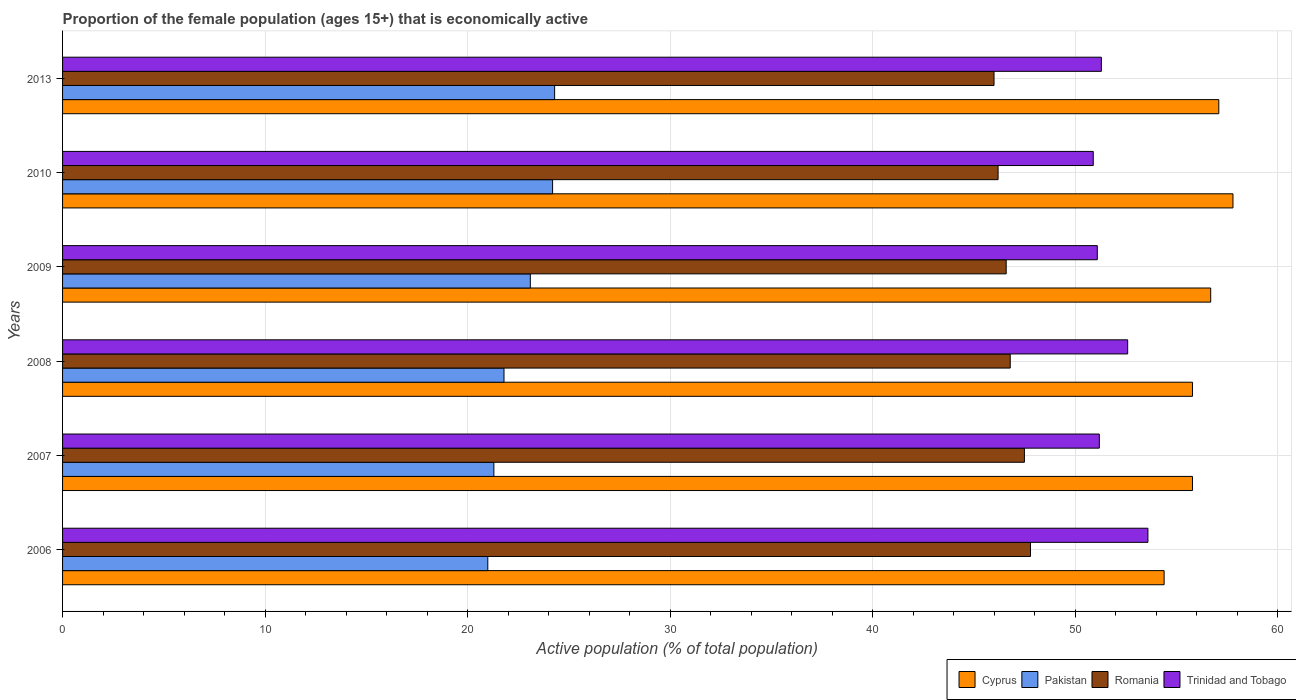How many different coloured bars are there?
Make the answer very short. 4. Are the number of bars on each tick of the Y-axis equal?
Make the answer very short. Yes. How many bars are there on the 4th tick from the top?
Offer a terse response. 4. What is the proportion of the female population that is economically active in Trinidad and Tobago in 2008?
Keep it short and to the point. 52.6. Across all years, what is the maximum proportion of the female population that is economically active in Pakistan?
Give a very brief answer. 24.3. Across all years, what is the minimum proportion of the female population that is economically active in Cyprus?
Keep it short and to the point. 54.4. In which year was the proportion of the female population that is economically active in Cyprus minimum?
Ensure brevity in your answer.  2006. What is the total proportion of the female population that is economically active in Romania in the graph?
Make the answer very short. 280.9. What is the difference between the proportion of the female population that is economically active in Trinidad and Tobago in 2008 and that in 2013?
Provide a succinct answer. 1.3. What is the difference between the proportion of the female population that is economically active in Cyprus in 2006 and the proportion of the female population that is economically active in Trinidad and Tobago in 2009?
Provide a short and direct response. 3.3. What is the average proportion of the female population that is economically active in Romania per year?
Make the answer very short. 46.82. What is the ratio of the proportion of the female population that is economically active in Romania in 2008 to that in 2010?
Your response must be concise. 1.01. Is the proportion of the female population that is economically active in Pakistan in 2008 less than that in 2013?
Provide a short and direct response. Yes. Is the difference between the proportion of the female population that is economically active in Romania in 2009 and 2013 greater than the difference between the proportion of the female population that is economically active in Trinidad and Tobago in 2009 and 2013?
Your answer should be compact. Yes. What is the difference between the highest and the lowest proportion of the female population that is economically active in Pakistan?
Provide a succinct answer. 3.3. Is the sum of the proportion of the female population that is economically active in Pakistan in 2006 and 2010 greater than the maximum proportion of the female population that is economically active in Trinidad and Tobago across all years?
Provide a short and direct response. No. Is it the case that in every year, the sum of the proportion of the female population that is economically active in Pakistan and proportion of the female population that is economically active in Cyprus is greater than the sum of proportion of the female population that is economically active in Trinidad and Tobago and proportion of the female population that is economically active in Romania?
Provide a succinct answer. No. What does the 4th bar from the top in 2010 represents?
Offer a very short reply. Cyprus. What does the 2nd bar from the bottom in 2010 represents?
Give a very brief answer. Pakistan. Is it the case that in every year, the sum of the proportion of the female population that is economically active in Pakistan and proportion of the female population that is economically active in Romania is greater than the proportion of the female population that is economically active in Trinidad and Tobago?
Your response must be concise. Yes. How many bars are there?
Your answer should be very brief. 24. Are the values on the major ticks of X-axis written in scientific E-notation?
Provide a succinct answer. No. How many legend labels are there?
Keep it short and to the point. 4. How are the legend labels stacked?
Provide a short and direct response. Horizontal. What is the title of the graph?
Offer a very short reply. Proportion of the female population (ages 15+) that is economically active. Does "Lower middle income" appear as one of the legend labels in the graph?
Your answer should be very brief. No. What is the label or title of the X-axis?
Make the answer very short. Active population (% of total population). What is the label or title of the Y-axis?
Your response must be concise. Years. What is the Active population (% of total population) of Cyprus in 2006?
Give a very brief answer. 54.4. What is the Active population (% of total population) of Pakistan in 2006?
Your answer should be very brief. 21. What is the Active population (% of total population) in Romania in 2006?
Provide a short and direct response. 47.8. What is the Active population (% of total population) in Trinidad and Tobago in 2006?
Offer a very short reply. 53.6. What is the Active population (% of total population) of Cyprus in 2007?
Make the answer very short. 55.8. What is the Active population (% of total population) in Pakistan in 2007?
Your answer should be compact. 21.3. What is the Active population (% of total population) in Romania in 2007?
Offer a terse response. 47.5. What is the Active population (% of total population) in Trinidad and Tobago in 2007?
Your answer should be very brief. 51.2. What is the Active population (% of total population) in Cyprus in 2008?
Offer a very short reply. 55.8. What is the Active population (% of total population) of Pakistan in 2008?
Offer a very short reply. 21.8. What is the Active population (% of total population) of Romania in 2008?
Keep it short and to the point. 46.8. What is the Active population (% of total population) in Trinidad and Tobago in 2008?
Provide a short and direct response. 52.6. What is the Active population (% of total population) in Cyprus in 2009?
Offer a very short reply. 56.7. What is the Active population (% of total population) of Pakistan in 2009?
Make the answer very short. 23.1. What is the Active population (% of total population) of Romania in 2009?
Your response must be concise. 46.6. What is the Active population (% of total population) of Trinidad and Tobago in 2009?
Give a very brief answer. 51.1. What is the Active population (% of total population) in Cyprus in 2010?
Ensure brevity in your answer.  57.8. What is the Active population (% of total population) in Pakistan in 2010?
Your response must be concise. 24.2. What is the Active population (% of total population) in Romania in 2010?
Give a very brief answer. 46.2. What is the Active population (% of total population) in Trinidad and Tobago in 2010?
Make the answer very short. 50.9. What is the Active population (% of total population) of Cyprus in 2013?
Keep it short and to the point. 57.1. What is the Active population (% of total population) in Pakistan in 2013?
Your answer should be compact. 24.3. What is the Active population (% of total population) of Trinidad and Tobago in 2013?
Your response must be concise. 51.3. Across all years, what is the maximum Active population (% of total population) of Cyprus?
Provide a succinct answer. 57.8. Across all years, what is the maximum Active population (% of total population) of Pakistan?
Provide a short and direct response. 24.3. Across all years, what is the maximum Active population (% of total population) of Romania?
Keep it short and to the point. 47.8. Across all years, what is the maximum Active population (% of total population) in Trinidad and Tobago?
Your answer should be very brief. 53.6. Across all years, what is the minimum Active population (% of total population) of Cyprus?
Ensure brevity in your answer.  54.4. Across all years, what is the minimum Active population (% of total population) in Pakistan?
Provide a short and direct response. 21. Across all years, what is the minimum Active population (% of total population) in Romania?
Offer a terse response. 46. Across all years, what is the minimum Active population (% of total population) in Trinidad and Tobago?
Your response must be concise. 50.9. What is the total Active population (% of total population) in Cyprus in the graph?
Provide a short and direct response. 337.6. What is the total Active population (% of total population) of Pakistan in the graph?
Keep it short and to the point. 135.7. What is the total Active population (% of total population) of Romania in the graph?
Keep it short and to the point. 280.9. What is the total Active population (% of total population) of Trinidad and Tobago in the graph?
Your answer should be compact. 310.7. What is the difference between the Active population (% of total population) in Pakistan in 2006 and that in 2007?
Provide a succinct answer. -0.3. What is the difference between the Active population (% of total population) of Romania in 2006 and that in 2008?
Your answer should be very brief. 1. What is the difference between the Active population (% of total population) of Trinidad and Tobago in 2006 and that in 2008?
Offer a very short reply. 1. What is the difference between the Active population (% of total population) in Cyprus in 2006 and that in 2009?
Your response must be concise. -2.3. What is the difference between the Active population (% of total population) of Pakistan in 2006 and that in 2009?
Provide a short and direct response. -2.1. What is the difference between the Active population (% of total population) in Trinidad and Tobago in 2006 and that in 2009?
Your answer should be compact. 2.5. What is the difference between the Active population (% of total population) of Cyprus in 2006 and that in 2010?
Your response must be concise. -3.4. What is the difference between the Active population (% of total population) of Romania in 2006 and that in 2010?
Your answer should be compact. 1.6. What is the difference between the Active population (% of total population) in Trinidad and Tobago in 2006 and that in 2010?
Give a very brief answer. 2.7. What is the difference between the Active population (% of total population) in Pakistan in 2007 and that in 2008?
Your answer should be very brief. -0.5. What is the difference between the Active population (% of total population) in Trinidad and Tobago in 2007 and that in 2008?
Provide a succinct answer. -1.4. What is the difference between the Active population (% of total population) in Pakistan in 2007 and that in 2009?
Your answer should be compact. -1.8. What is the difference between the Active population (% of total population) of Trinidad and Tobago in 2007 and that in 2009?
Your answer should be very brief. 0.1. What is the difference between the Active population (% of total population) in Pakistan in 2007 and that in 2010?
Offer a very short reply. -2.9. What is the difference between the Active population (% of total population) of Romania in 2007 and that in 2013?
Make the answer very short. 1.5. What is the difference between the Active population (% of total population) of Trinidad and Tobago in 2007 and that in 2013?
Provide a succinct answer. -0.1. What is the difference between the Active population (% of total population) of Romania in 2008 and that in 2009?
Keep it short and to the point. 0.2. What is the difference between the Active population (% of total population) in Trinidad and Tobago in 2008 and that in 2009?
Your answer should be very brief. 1.5. What is the difference between the Active population (% of total population) of Romania in 2008 and that in 2010?
Provide a short and direct response. 0.6. What is the difference between the Active population (% of total population) of Cyprus in 2008 and that in 2013?
Provide a succinct answer. -1.3. What is the difference between the Active population (% of total population) in Pakistan in 2008 and that in 2013?
Provide a succinct answer. -2.5. What is the difference between the Active population (% of total population) of Trinidad and Tobago in 2008 and that in 2013?
Ensure brevity in your answer.  1.3. What is the difference between the Active population (% of total population) of Trinidad and Tobago in 2009 and that in 2010?
Keep it short and to the point. 0.2. What is the difference between the Active population (% of total population) in Cyprus in 2009 and that in 2013?
Give a very brief answer. -0.4. What is the difference between the Active population (% of total population) of Romania in 2009 and that in 2013?
Make the answer very short. 0.6. What is the difference between the Active population (% of total population) in Trinidad and Tobago in 2009 and that in 2013?
Your answer should be compact. -0.2. What is the difference between the Active population (% of total population) of Cyprus in 2010 and that in 2013?
Provide a succinct answer. 0.7. What is the difference between the Active population (% of total population) of Pakistan in 2010 and that in 2013?
Give a very brief answer. -0.1. What is the difference between the Active population (% of total population) of Romania in 2010 and that in 2013?
Offer a very short reply. 0.2. What is the difference between the Active population (% of total population) of Trinidad and Tobago in 2010 and that in 2013?
Offer a terse response. -0.4. What is the difference between the Active population (% of total population) in Cyprus in 2006 and the Active population (% of total population) in Pakistan in 2007?
Your answer should be compact. 33.1. What is the difference between the Active population (% of total population) of Pakistan in 2006 and the Active population (% of total population) of Romania in 2007?
Give a very brief answer. -26.5. What is the difference between the Active population (% of total population) of Pakistan in 2006 and the Active population (% of total population) of Trinidad and Tobago in 2007?
Make the answer very short. -30.2. What is the difference between the Active population (% of total population) in Cyprus in 2006 and the Active population (% of total population) in Pakistan in 2008?
Give a very brief answer. 32.6. What is the difference between the Active population (% of total population) in Cyprus in 2006 and the Active population (% of total population) in Romania in 2008?
Your answer should be compact. 7.6. What is the difference between the Active population (% of total population) in Cyprus in 2006 and the Active population (% of total population) in Trinidad and Tobago in 2008?
Your response must be concise. 1.8. What is the difference between the Active population (% of total population) of Pakistan in 2006 and the Active population (% of total population) of Romania in 2008?
Offer a very short reply. -25.8. What is the difference between the Active population (% of total population) of Pakistan in 2006 and the Active population (% of total population) of Trinidad and Tobago in 2008?
Offer a very short reply. -31.6. What is the difference between the Active population (% of total population) in Romania in 2006 and the Active population (% of total population) in Trinidad and Tobago in 2008?
Provide a short and direct response. -4.8. What is the difference between the Active population (% of total population) of Cyprus in 2006 and the Active population (% of total population) of Pakistan in 2009?
Your response must be concise. 31.3. What is the difference between the Active population (% of total population) of Pakistan in 2006 and the Active population (% of total population) of Romania in 2009?
Make the answer very short. -25.6. What is the difference between the Active population (% of total population) of Pakistan in 2006 and the Active population (% of total population) of Trinidad and Tobago in 2009?
Keep it short and to the point. -30.1. What is the difference between the Active population (% of total population) of Romania in 2006 and the Active population (% of total population) of Trinidad and Tobago in 2009?
Give a very brief answer. -3.3. What is the difference between the Active population (% of total population) of Cyprus in 2006 and the Active population (% of total population) of Pakistan in 2010?
Keep it short and to the point. 30.2. What is the difference between the Active population (% of total population) in Cyprus in 2006 and the Active population (% of total population) in Romania in 2010?
Provide a succinct answer. 8.2. What is the difference between the Active population (% of total population) in Cyprus in 2006 and the Active population (% of total population) in Trinidad and Tobago in 2010?
Your answer should be very brief. 3.5. What is the difference between the Active population (% of total population) of Pakistan in 2006 and the Active population (% of total population) of Romania in 2010?
Your response must be concise. -25.2. What is the difference between the Active population (% of total population) in Pakistan in 2006 and the Active population (% of total population) in Trinidad and Tobago in 2010?
Provide a succinct answer. -29.9. What is the difference between the Active population (% of total population) in Cyprus in 2006 and the Active population (% of total population) in Pakistan in 2013?
Provide a short and direct response. 30.1. What is the difference between the Active population (% of total population) of Cyprus in 2006 and the Active population (% of total population) of Trinidad and Tobago in 2013?
Make the answer very short. 3.1. What is the difference between the Active population (% of total population) in Pakistan in 2006 and the Active population (% of total population) in Romania in 2013?
Ensure brevity in your answer.  -25. What is the difference between the Active population (% of total population) in Pakistan in 2006 and the Active population (% of total population) in Trinidad and Tobago in 2013?
Ensure brevity in your answer.  -30.3. What is the difference between the Active population (% of total population) of Cyprus in 2007 and the Active population (% of total population) of Trinidad and Tobago in 2008?
Ensure brevity in your answer.  3.2. What is the difference between the Active population (% of total population) of Pakistan in 2007 and the Active population (% of total population) of Romania in 2008?
Offer a very short reply. -25.5. What is the difference between the Active population (% of total population) in Pakistan in 2007 and the Active population (% of total population) in Trinidad and Tobago in 2008?
Provide a short and direct response. -31.3. What is the difference between the Active population (% of total population) of Romania in 2007 and the Active population (% of total population) of Trinidad and Tobago in 2008?
Give a very brief answer. -5.1. What is the difference between the Active population (% of total population) of Cyprus in 2007 and the Active population (% of total population) of Pakistan in 2009?
Make the answer very short. 32.7. What is the difference between the Active population (% of total population) of Cyprus in 2007 and the Active population (% of total population) of Romania in 2009?
Offer a terse response. 9.2. What is the difference between the Active population (% of total population) of Cyprus in 2007 and the Active population (% of total population) of Trinidad and Tobago in 2009?
Your answer should be very brief. 4.7. What is the difference between the Active population (% of total population) in Pakistan in 2007 and the Active population (% of total population) in Romania in 2009?
Make the answer very short. -25.3. What is the difference between the Active population (% of total population) of Pakistan in 2007 and the Active population (% of total population) of Trinidad and Tobago in 2009?
Give a very brief answer. -29.8. What is the difference between the Active population (% of total population) of Romania in 2007 and the Active population (% of total population) of Trinidad and Tobago in 2009?
Offer a terse response. -3.6. What is the difference between the Active population (% of total population) in Cyprus in 2007 and the Active population (% of total population) in Pakistan in 2010?
Keep it short and to the point. 31.6. What is the difference between the Active population (% of total population) in Cyprus in 2007 and the Active population (% of total population) in Romania in 2010?
Offer a terse response. 9.6. What is the difference between the Active population (% of total population) of Cyprus in 2007 and the Active population (% of total population) of Trinidad and Tobago in 2010?
Provide a short and direct response. 4.9. What is the difference between the Active population (% of total population) of Pakistan in 2007 and the Active population (% of total population) of Romania in 2010?
Ensure brevity in your answer.  -24.9. What is the difference between the Active population (% of total population) in Pakistan in 2007 and the Active population (% of total population) in Trinidad and Tobago in 2010?
Provide a succinct answer. -29.6. What is the difference between the Active population (% of total population) of Cyprus in 2007 and the Active population (% of total population) of Pakistan in 2013?
Your answer should be compact. 31.5. What is the difference between the Active population (% of total population) of Cyprus in 2007 and the Active population (% of total population) of Romania in 2013?
Offer a terse response. 9.8. What is the difference between the Active population (% of total population) of Pakistan in 2007 and the Active population (% of total population) of Romania in 2013?
Give a very brief answer. -24.7. What is the difference between the Active population (% of total population) of Cyprus in 2008 and the Active population (% of total population) of Pakistan in 2009?
Make the answer very short. 32.7. What is the difference between the Active population (% of total population) in Cyprus in 2008 and the Active population (% of total population) in Romania in 2009?
Your response must be concise. 9.2. What is the difference between the Active population (% of total population) in Pakistan in 2008 and the Active population (% of total population) in Romania in 2009?
Ensure brevity in your answer.  -24.8. What is the difference between the Active population (% of total population) of Pakistan in 2008 and the Active population (% of total population) of Trinidad and Tobago in 2009?
Your response must be concise. -29.3. What is the difference between the Active population (% of total population) of Cyprus in 2008 and the Active population (% of total population) of Pakistan in 2010?
Provide a short and direct response. 31.6. What is the difference between the Active population (% of total population) in Cyprus in 2008 and the Active population (% of total population) in Romania in 2010?
Provide a succinct answer. 9.6. What is the difference between the Active population (% of total population) of Pakistan in 2008 and the Active population (% of total population) of Romania in 2010?
Offer a very short reply. -24.4. What is the difference between the Active population (% of total population) of Pakistan in 2008 and the Active population (% of total population) of Trinidad and Tobago in 2010?
Ensure brevity in your answer.  -29.1. What is the difference between the Active population (% of total population) of Cyprus in 2008 and the Active population (% of total population) of Pakistan in 2013?
Offer a terse response. 31.5. What is the difference between the Active population (% of total population) in Cyprus in 2008 and the Active population (% of total population) in Trinidad and Tobago in 2013?
Provide a short and direct response. 4.5. What is the difference between the Active population (% of total population) in Pakistan in 2008 and the Active population (% of total population) in Romania in 2013?
Provide a short and direct response. -24.2. What is the difference between the Active population (% of total population) of Pakistan in 2008 and the Active population (% of total population) of Trinidad and Tobago in 2013?
Offer a terse response. -29.5. What is the difference between the Active population (% of total population) of Romania in 2008 and the Active population (% of total population) of Trinidad and Tobago in 2013?
Provide a short and direct response. -4.5. What is the difference between the Active population (% of total population) in Cyprus in 2009 and the Active population (% of total population) in Pakistan in 2010?
Your answer should be compact. 32.5. What is the difference between the Active population (% of total population) of Cyprus in 2009 and the Active population (% of total population) of Romania in 2010?
Provide a short and direct response. 10.5. What is the difference between the Active population (% of total population) of Pakistan in 2009 and the Active population (% of total population) of Romania in 2010?
Your answer should be compact. -23.1. What is the difference between the Active population (% of total population) in Pakistan in 2009 and the Active population (% of total population) in Trinidad and Tobago in 2010?
Keep it short and to the point. -27.8. What is the difference between the Active population (% of total population) of Romania in 2009 and the Active population (% of total population) of Trinidad and Tobago in 2010?
Provide a succinct answer. -4.3. What is the difference between the Active population (% of total population) of Cyprus in 2009 and the Active population (% of total population) of Pakistan in 2013?
Provide a succinct answer. 32.4. What is the difference between the Active population (% of total population) of Pakistan in 2009 and the Active population (% of total population) of Romania in 2013?
Your answer should be compact. -22.9. What is the difference between the Active population (% of total population) of Pakistan in 2009 and the Active population (% of total population) of Trinidad and Tobago in 2013?
Your answer should be very brief. -28.2. What is the difference between the Active population (% of total population) in Romania in 2009 and the Active population (% of total population) in Trinidad and Tobago in 2013?
Ensure brevity in your answer.  -4.7. What is the difference between the Active population (% of total population) in Cyprus in 2010 and the Active population (% of total population) in Pakistan in 2013?
Your answer should be compact. 33.5. What is the difference between the Active population (% of total population) of Pakistan in 2010 and the Active population (% of total population) of Romania in 2013?
Provide a succinct answer. -21.8. What is the difference between the Active population (% of total population) in Pakistan in 2010 and the Active population (% of total population) in Trinidad and Tobago in 2013?
Your response must be concise. -27.1. What is the difference between the Active population (% of total population) in Romania in 2010 and the Active population (% of total population) in Trinidad and Tobago in 2013?
Your answer should be very brief. -5.1. What is the average Active population (% of total population) of Cyprus per year?
Ensure brevity in your answer.  56.27. What is the average Active population (% of total population) of Pakistan per year?
Provide a short and direct response. 22.62. What is the average Active population (% of total population) of Romania per year?
Ensure brevity in your answer.  46.82. What is the average Active population (% of total population) in Trinidad and Tobago per year?
Your answer should be compact. 51.78. In the year 2006, what is the difference between the Active population (% of total population) of Cyprus and Active population (% of total population) of Pakistan?
Offer a terse response. 33.4. In the year 2006, what is the difference between the Active population (% of total population) of Cyprus and Active population (% of total population) of Romania?
Make the answer very short. 6.6. In the year 2006, what is the difference between the Active population (% of total population) of Cyprus and Active population (% of total population) of Trinidad and Tobago?
Offer a very short reply. 0.8. In the year 2006, what is the difference between the Active population (% of total population) in Pakistan and Active population (% of total population) in Romania?
Offer a very short reply. -26.8. In the year 2006, what is the difference between the Active population (% of total population) in Pakistan and Active population (% of total population) in Trinidad and Tobago?
Offer a terse response. -32.6. In the year 2006, what is the difference between the Active population (% of total population) of Romania and Active population (% of total population) of Trinidad and Tobago?
Make the answer very short. -5.8. In the year 2007, what is the difference between the Active population (% of total population) in Cyprus and Active population (% of total population) in Pakistan?
Your answer should be compact. 34.5. In the year 2007, what is the difference between the Active population (% of total population) in Pakistan and Active population (% of total population) in Romania?
Your response must be concise. -26.2. In the year 2007, what is the difference between the Active population (% of total population) of Pakistan and Active population (% of total population) of Trinidad and Tobago?
Make the answer very short. -29.9. In the year 2007, what is the difference between the Active population (% of total population) in Romania and Active population (% of total population) in Trinidad and Tobago?
Offer a terse response. -3.7. In the year 2008, what is the difference between the Active population (% of total population) of Cyprus and Active population (% of total population) of Pakistan?
Ensure brevity in your answer.  34. In the year 2008, what is the difference between the Active population (% of total population) in Cyprus and Active population (% of total population) in Romania?
Your response must be concise. 9. In the year 2008, what is the difference between the Active population (% of total population) of Pakistan and Active population (% of total population) of Romania?
Give a very brief answer. -25. In the year 2008, what is the difference between the Active population (% of total population) in Pakistan and Active population (% of total population) in Trinidad and Tobago?
Keep it short and to the point. -30.8. In the year 2009, what is the difference between the Active population (% of total population) of Cyprus and Active population (% of total population) of Pakistan?
Provide a short and direct response. 33.6. In the year 2009, what is the difference between the Active population (% of total population) of Pakistan and Active population (% of total population) of Romania?
Your answer should be very brief. -23.5. In the year 2009, what is the difference between the Active population (% of total population) of Romania and Active population (% of total population) of Trinidad and Tobago?
Make the answer very short. -4.5. In the year 2010, what is the difference between the Active population (% of total population) in Cyprus and Active population (% of total population) in Pakistan?
Your response must be concise. 33.6. In the year 2010, what is the difference between the Active population (% of total population) of Cyprus and Active population (% of total population) of Romania?
Your response must be concise. 11.6. In the year 2010, what is the difference between the Active population (% of total population) in Pakistan and Active population (% of total population) in Romania?
Your answer should be compact. -22. In the year 2010, what is the difference between the Active population (% of total population) in Pakistan and Active population (% of total population) in Trinidad and Tobago?
Provide a succinct answer. -26.7. In the year 2013, what is the difference between the Active population (% of total population) of Cyprus and Active population (% of total population) of Pakistan?
Offer a terse response. 32.8. In the year 2013, what is the difference between the Active population (% of total population) of Cyprus and Active population (% of total population) of Trinidad and Tobago?
Offer a terse response. 5.8. In the year 2013, what is the difference between the Active population (% of total population) in Pakistan and Active population (% of total population) in Romania?
Make the answer very short. -21.7. What is the ratio of the Active population (% of total population) of Cyprus in 2006 to that in 2007?
Offer a terse response. 0.97. What is the ratio of the Active population (% of total population) of Pakistan in 2006 to that in 2007?
Your answer should be compact. 0.99. What is the ratio of the Active population (% of total population) of Romania in 2006 to that in 2007?
Your answer should be very brief. 1.01. What is the ratio of the Active population (% of total population) of Trinidad and Tobago in 2006 to that in 2007?
Give a very brief answer. 1.05. What is the ratio of the Active population (% of total population) of Cyprus in 2006 to that in 2008?
Provide a succinct answer. 0.97. What is the ratio of the Active population (% of total population) in Pakistan in 2006 to that in 2008?
Make the answer very short. 0.96. What is the ratio of the Active population (% of total population) in Romania in 2006 to that in 2008?
Keep it short and to the point. 1.02. What is the ratio of the Active population (% of total population) of Trinidad and Tobago in 2006 to that in 2008?
Make the answer very short. 1.02. What is the ratio of the Active population (% of total population) in Cyprus in 2006 to that in 2009?
Give a very brief answer. 0.96. What is the ratio of the Active population (% of total population) in Romania in 2006 to that in 2009?
Offer a terse response. 1.03. What is the ratio of the Active population (% of total population) in Trinidad and Tobago in 2006 to that in 2009?
Offer a terse response. 1.05. What is the ratio of the Active population (% of total population) in Pakistan in 2006 to that in 2010?
Offer a terse response. 0.87. What is the ratio of the Active population (% of total population) in Romania in 2006 to that in 2010?
Make the answer very short. 1.03. What is the ratio of the Active population (% of total population) of Trinidad and Tobago in 2006 to that in 2010?
Make the answer very short. 1.05. What is the ratio of the Active population (% of total population) of Cyprus in 2006 to that in 2013?
Your response must be concise. 0.95. What is the ratio of the Active population (% of total population) of Pakistan in 2006 to that in 2013?
Keep it short and to the point. 0.86. What is the ratio of the Active population (% of total population) of Romania in 2006 to that in 2013?
Ensure brevity in your answer.  1.04. What is the ratio of the Active population (% of total population) in Trinidad and Tobago in 2006 to that in 2013?
Provide a succinct answer. 1.04. What is the ratio of the Active population (% of total population) of Pakistan in 2007 to that in 2008?
Your answer should be very brief. 0.98. What is the ratio of the Active population (% of total population) in Romania in 2007 to that in 2008?
Offer a terse response. 1.01. What is the ratio of the Active population (% of total population) of Trinidad and Tobago in 2007 to that in 2008?
Give a very brief answer. 0.97. What is the ratio of the Active population (% of total population) of Cyprus in 2007 to that in 2009?
Give a very brief answer. 0.98. What is the ratio of the Active population (% of total population) in Pakistan in 2007 to that in 2009?
Make the answer very short. 0.92. What is the ratio of the Active population (% of total population) of Romania in 2007 to that in 2009?
Offer a terse response. 1.02. What is the ratio of the Active population (% of total population) of Cyprus in 2007 to that in 2010?
Give a very brief answer. 0.97. What is the ratio of the Active population (% of total population) in Pakistan in 2007 to that in 2010?
Provide a succinct answer. 0.88. What is the ratio of the Active population (% of total population) of Romania in 2007 to that in 2010?
Provide a succinct answer. 1.03. What is the ratio of the Active population (% of total population) in Trinidad and Tobago in 2007 to that in 2010?
Ensure brevity in your answer.  1.01. What is the ratio of the Active population (% of total population) in Cyprus in 2007 to that in 2013?
Ensure brevity in your answer.  0.98. What is the ratio of the Active population (% of total population) of Pakistan in 2007 to that in 2013?
Ensure brevity in your answer.  0.88. What is the ratio of the Active population (% of total population) of Romania in 2007 to that in 2013?
Provide a succinct answer. 1.03. What is the ratio of the Active population (% of total population) in Trinidad and Tobago in 2007 to that in 2013?
Make the answer very short. 1. What is the ratio of the Active population (% of total population) of Cyprus in 2008 to that in 2009?
Offer a terse response. 0.98. What is the ratio of the Active population (% of total population) in Pakistan in 2008 to that in 2009?
Keep it short and to the point. 0.94. What is the ratio of the Active population (% of total population) in Trinidad and Tobago in 2008 to that in 2009?
Make the answer very short. 1.03. What is the ratio of the Active population (% of total population) of Cyprus in 2008 to that in 2010?
Provide a short and direct response. 0.97. What is the ratio of the Active population (% of total population) of Pakistan in 2008 to that in 2010?
Ensure brevity in your answer.  0.9. What is the ratio of the Active population (% of total population) of Romania in 2008 to that in 2010?
Offer a very short reply. 1.01. What is the ratio of the Active population (% of total population) in Trinidad and Tobago in 2008 to that in 2010?
Give a very brief answer. 1.03. What is the ratio of the Active population (% of total population) in Cyprus in 2008 to that in 2013?
Keep it short and to the point. 0.98. What is the ratio of the Active population (% of total population) in Pakistan in 2008 to that in 2013?
Provide a short and direct response. 0.9. What is the ratio of the Active population (% of total population) of Romania in 2008 to that in 2013?
Make the answer very short. 1.02. What is the ratio of the Active population (% of total population) of Trinidad and Tobago in 2008 to that in 2013?
Your answer should be compact. 1.03. What is the ratio of the Active population (% of total population) in Pakistan in 2009 to that in 2010?
Ensure brevity in your answer.  0.95. What is the ratio of the Active population (% of total population) in Romania in 2009 to that in 2010?
Offer a terse response. 1.01. What is the ratio of the Active population (% of total population) in Trinidad and Tobago in 2009 to that in 2010?
Give a very brief answer. 1. What is the ratio of the Active population (% of total population) of Pakistan in 2009 to that in 2013?
Your answer should be very brief. 0.95. What is the ratio of the Active population (% of total population) of Romania in 2009 to that in 2013?
Give a very brief answer. 1.01. What is the ratio of the Active population (% of total population) in Cyprus in 2010 to that in 2013?
Provide a succinct answer. 1.01. What is the ratio of the Active population (% of total population) of Pakistan in 2010 to that in 2013?
Provide a short and direct response. 1. What is the difference between the highest and the second highest Active population (% of total population) of Pakistan?
Your answer should be compact. 0.1. What is the difference between the highest and the lowest Active population (% of total population) in Cyprus?
Your response must be concise. 3.4. 